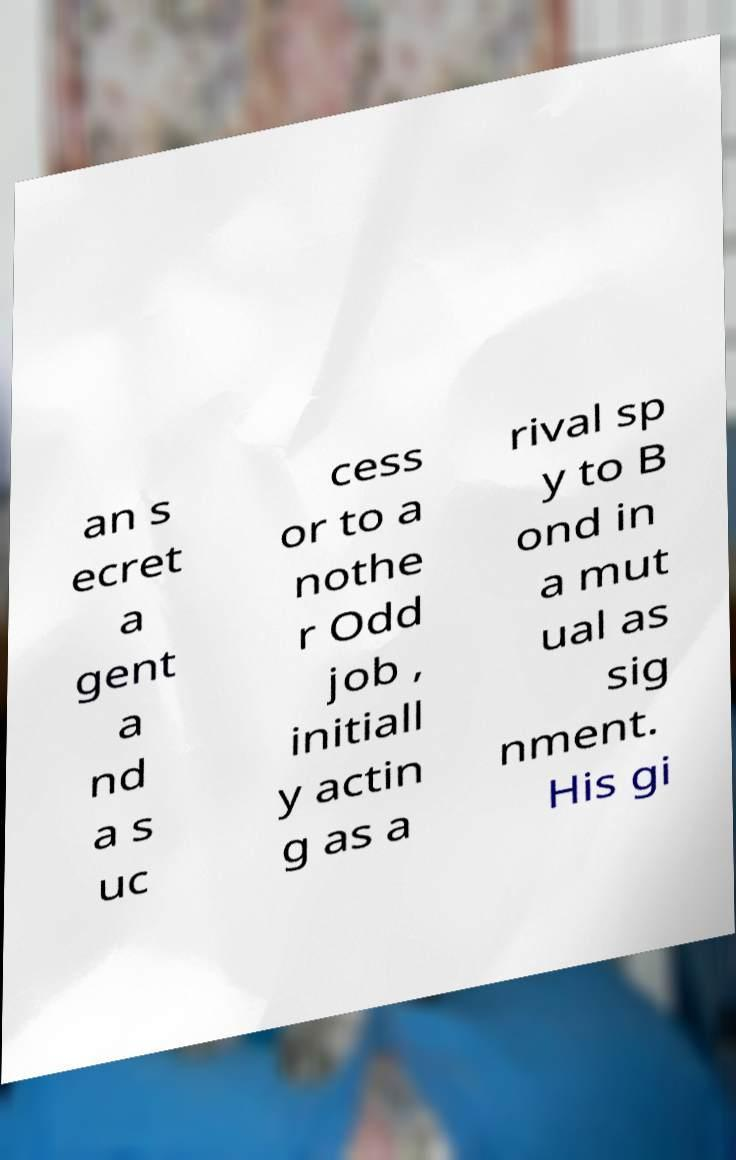There's text embedded in this image that I need extracted. Can you transcribe it verbatim? an s ecret a gent a nd a s uc cess or to a nothe r Odd job , initiall y actin g as a rival sp y to B ond in a mut ual as sig nment. His gi 